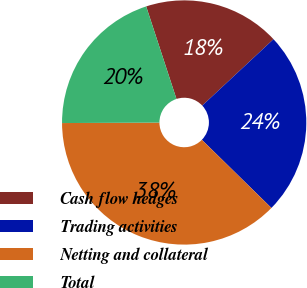Convert chart. <chart><loc_0><loc_0><loc_500><loc_500><pie_chart><fcel>Cash flow hedges<fcel>Trading activities<fcel>Netting and collateral<fcel>Total<nl><fcel>18.09%<fcel>24.28%<fcel>37.59%<fcel>20.04%<nl></chart> 